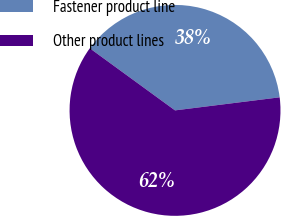Convert chart. <chart><loc_0><loc_0><loc_500><loc_500><pie_chart><fcel>Fastener product line<fcel>Other product lines<nl><fcel>38.0%<fcel>62.0%<nl></chart> 